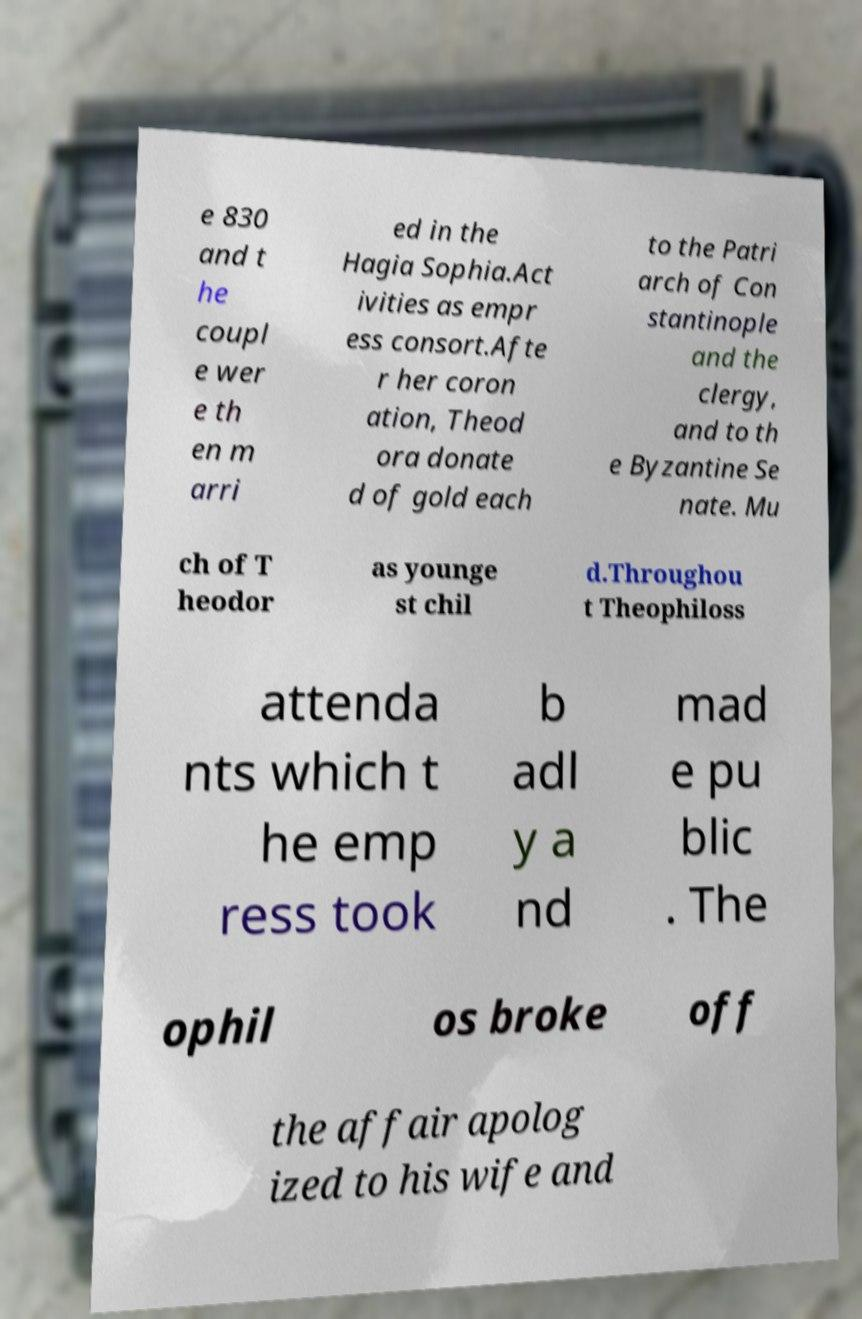Can you accurately transcribe the text from the provided image for me? e 830 and t he coupl e wer e th en m arri ed in the Hagia Sophia.Act ivities as empr ess consort.Afte r her coron ation, Theod ora donate d of gold each to the Patri arch of Con stantinople and the clergy, and to th e Byzantine Se nate. Mu ch of T heodor as younge st chil d.Throughou t Theophiloss attenda nts which t he emp ress took b adl y a nd mad e pu blic . The ophil os broke off the affair apolog ized to his wife and 